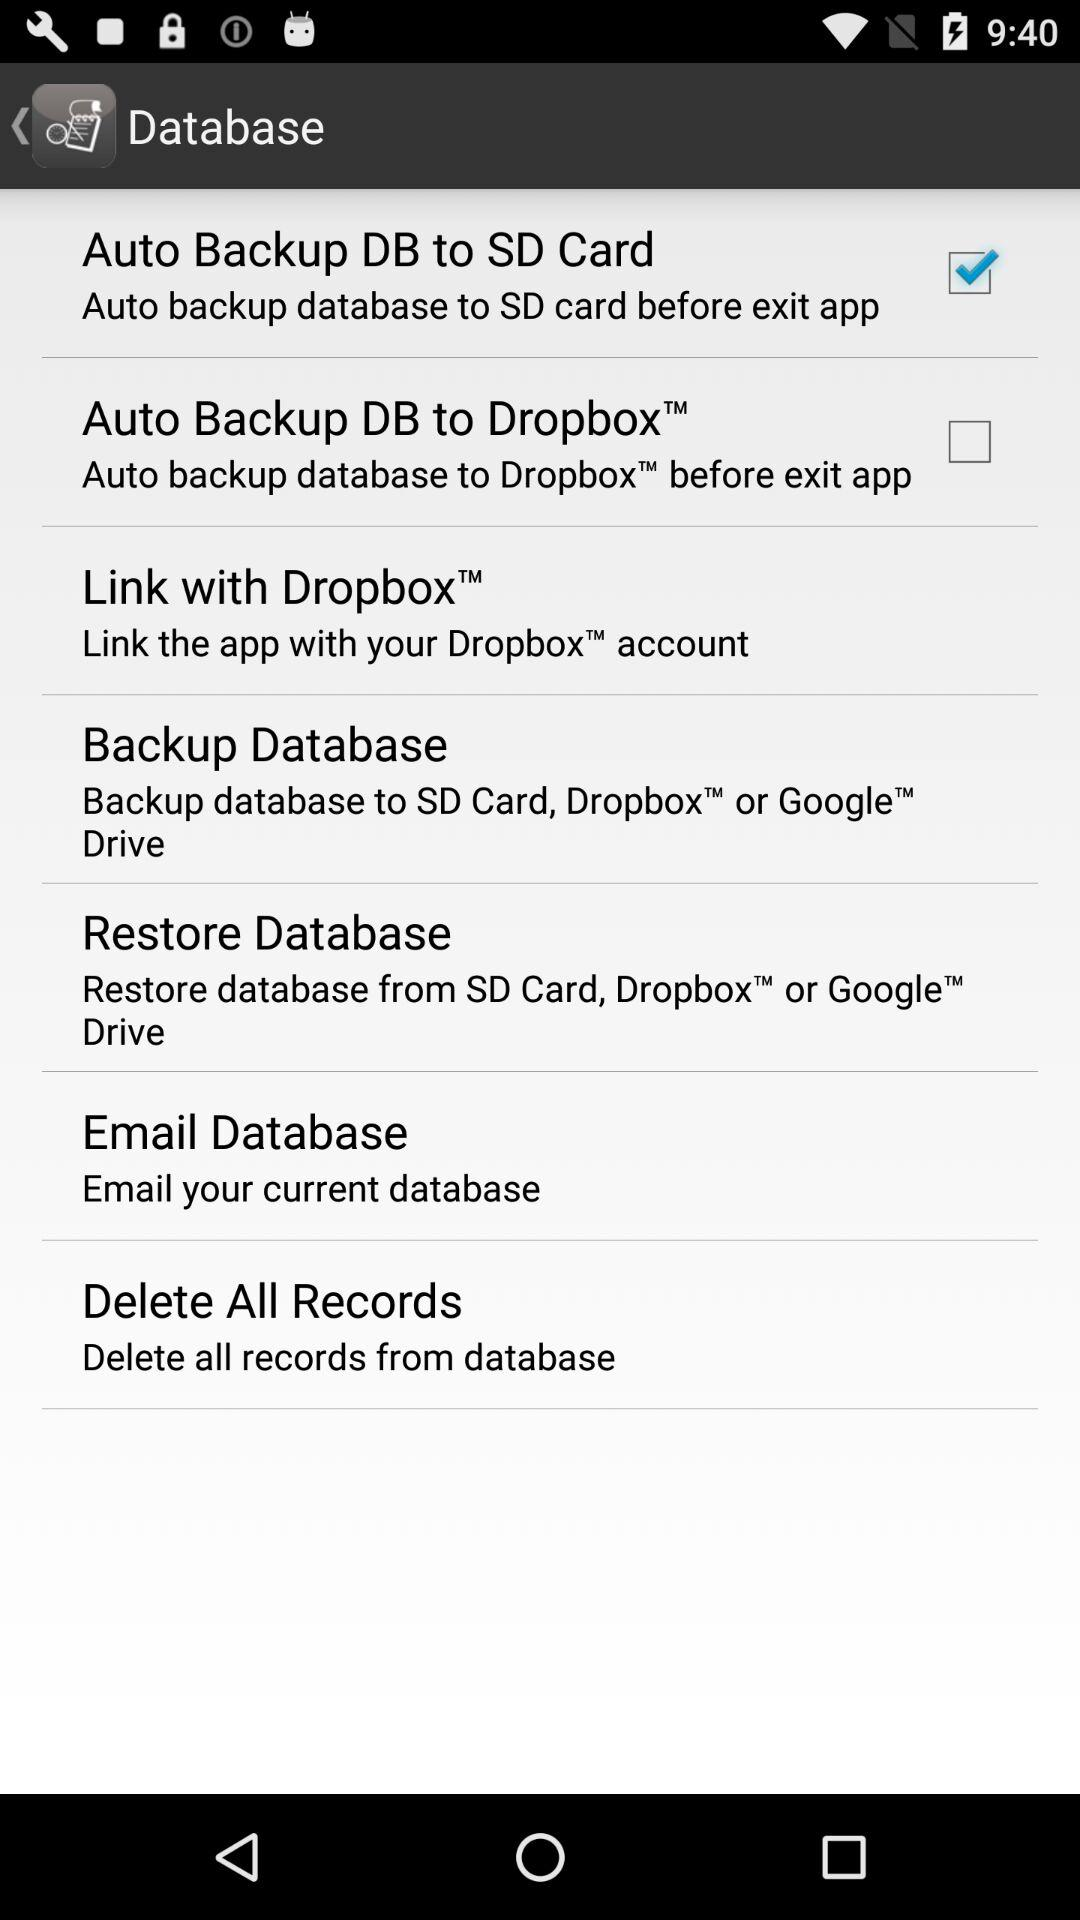What is the status of "Auto Backup DB to SD Card"? The status is on. 